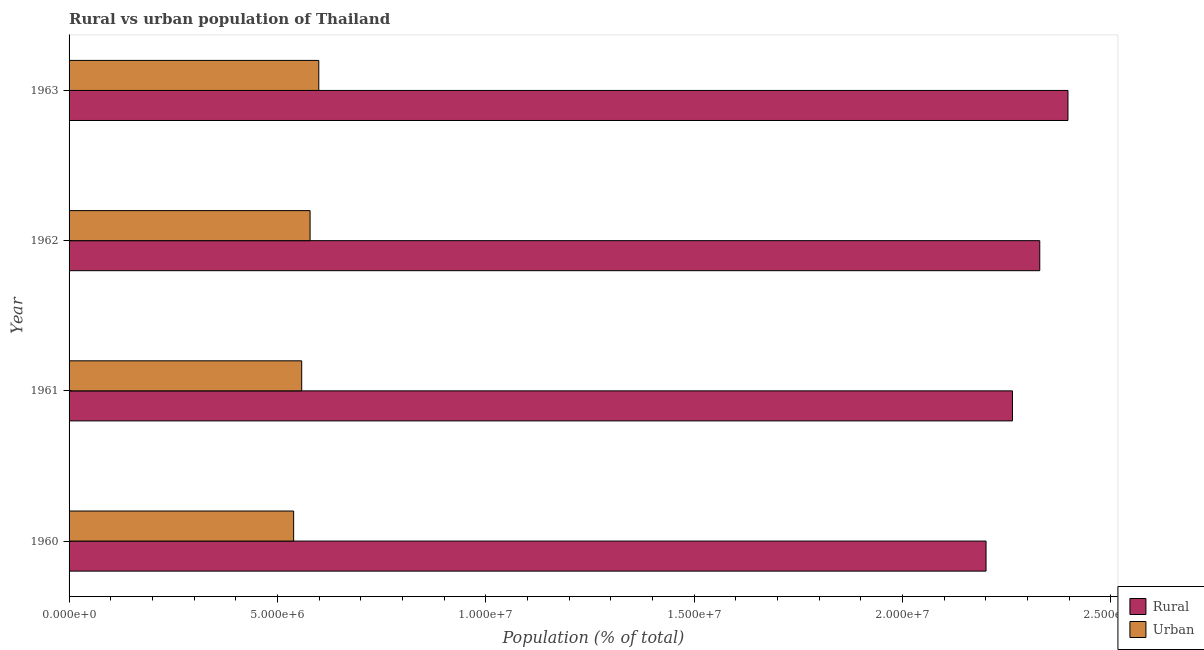How many different coloured bars are there?
Make the answer very short. 2. How many groups of bars are there?
Ensure brevity in your answer.  4. Are the number of bars per tick equal to the number of legend labels?
Keep it short and to the point. Yes. How many bars are there on the 2nd tick from the top?
Your answer should be very brief. 2. How many bars are there on the 3rd tick from the bottom?
Your answer should be compact. 2. What is the label of the 4th group of bars from the top?
Give a very brief answer. 1960. In how many cases, is the number of bars for a given year not equal to the number of legend labels?
Your answer should be compact. 0. What is the urban population density in 1962?
Offer a terse response. 5.78e+06. Across all years, what is the maximum urban population density?
Offer a very short reply. 5.99e+06. Across all years, what is the minimum urban population density?
Keep it short and to the point. 5.39e+06. In which year was the urban population density maximum?
Ensure brevity in your answer.  1963. What is the total urban population density in the graph?
Offer a terse response. 2.28e+07. What is the difference between the rural population density in 1960 and that in 1962?
Keep it short and to the point. -1.29e+06. What is the difference between the urban population density in 1963 and the rural population density in 1961?
Give a very brief answer. -1.66e+07. What is the average urban population density per year?
Your answer should be compact. 5.69e+06. In the year 1963, what is the difference between the rural population density and urban population density?
Your answer should be very brief. 1.80e+07. In how many years, is the rural population density greater than 18000000 %?
Your response must be concise. 4. What is the ratio of the rural population density in 1960 to that in 1963?
Offer a terse response. 0.92. What is the difference between the highest and the second highest rural population density?
Your answer should be very brief. 6.77e+05. What is the difference between the highest and the lowest rural population density?
Provide a succinct answer. 1.97e+06. In how many years, is the rural population density greater than the average rural population density taken over all years?
Your answer should be very brief. 2. What does the 2nd bar from the top in 1961 represents?
Give a very brief answer. Rural. What does the 1st bar from the bottom in 1960 represents?
Make the answer very short. Rural. Are all the bars in the graph horizontal?
Offer a terse response. Yes. What is the difference between two consecutive major ticks on the X-axis?
Give a very brief answer. 5.00e+06. Are the values on the major ticks of X-axis written in scientific E-notation?
Provide a succinct answer. Yes. Where does the legend appear in the graph?
Give a very brief answer. Bottom right. How many legend labels are there?
Offer a very short reply. 2. What is the title of the graph?
Your answer should be very brief. Rural vs urban population of Thailand. Does "US$" appear as one of the legend labels in the graph?
Provide a succinct answer. No. What is the label or title of the X-axis?
Give a very brief answer. Population (% of total). What is the label or title of the Y-axis?
Your answer should be very brief. Year. What is the Population (% of total) of Rural in 1960?
Provide a short and direct response. 2.20e+07. What is the Population (% of total) of Urban in 1960?
Your answer should be compact. 5.39e+06. What is the Population (% of total) of Rural in 1961?
Your answer should be compact. 2.26e+07. What is the Population (% of total) in Urban in 1961?
Offer a terse response. 5.58e+06. What is the Population (% of total) of Rural in 1962?
Offer a terse response. 2.33e+07. What is the Population (% of total) of Urban in 1962?
Your answer should be very brief. 5.78e+06. What is the Population (% of total) in Rural in 1963?
Give a very brief answer. 2.40e+07. What is the Population (% of total) of Urban in 1963?
Provide a short and direct response. 5.99e+06. Across all years, what is the maximum Population (% of total) in Rural?
Make the answer very short. 2.40e+07. Across all years, what is the maximum Population (% of total) of Urban?
Ensure brevity in your answer.  5.99e+06. Across all years, what is the minimum Population (% of total) in Rural?
Offer a very short reply. 2.20e+07. Across all years, what is the minimum Population (% of total) of Urban?
Keep it short and to the point. 5.39e+06. What is the total Population (% of total) in Rural in the graph?
Offer a terse response. 9.19e+07. What is the total Population (% of total) of Urban in the graph?
Keep it short and to the point. 2.28e+07. What is the difference between the Population (% of total) in Rural in 1960 and that in 1961?
Offer a very short reply. -6.34e+05. What is the difference between the Population (% of total) in Urban in 1960 and that in 1961?
Your answer should be compact. -1.93e+05. What is the difference between the Population (% of total) in Rural in 1960 and that in 1962?
Your answer should be very brief. -1.29e+06. What is the difference between the Population (% of total) of Urban in 1960 and that in 1962?
Make the answer very short. -3.95e+05. What is the difference between the Population (% of total) in Rural in 1960 and that in 1963?
Your answer should be very brief. -1.97e+06. What is the difference between the Population (% of total) of Urban in 1960 and that in 1963?
Offer a terse response. -6.04e+05. What is the difference between the Population (% of total) of Rural in 1961 and that in 1962?
Offer a very short reply. -6.56e+05. What is the difference between the Population (% of total) in Urban in 1961 and that in 1962?
Ensure brevity in your answer.  -2.01e+05. What is the difference between the Population (% of total) of Rural in 1961 and that in 1963?
Ensure brevity in your answer.  -1.33e+06. What is the difference between the Population (% of total) of Urban in 1961 and that in 1963?
Offer a very short reply. -4.10e+05. What is the difference between the Population (% of total) in Rural in 1962 and that in 1963?
Your answer should be compact. -6.77e+05. What is the difference between the Population (% of total) in Urban in 1962 and that in 1963?
Offer a very short reply. -2.09e+05. What is the difference between the Population (% of total) in Rural in 1960 and the Population (% of total) in Urban in 1961?
Provide a short and direct response. 1.64e+07. What is the difference between the Population (% of total) in Rural in 1960 and the Population (% of total) in Urban in 1962?
Your response must be concise. 1.62e+07. What is the difference between the Population (% of total) of Rural in 1960 and the Population (% of total) of Urban in 1963?
Offer a terse response. 1.60e+07. What is the difference between the Population (% of total) in Rural in 1961 and the Population (% of total) in Urban in 1962?
Your answer should be very brief. 1.69e+07. What is the difference between the Population (% of total) of Rural in 1961 and the Population (% of total) of Urban in 1963?
Provide a succinct answer. 1.66e+07. What is the difference between the Population (% of total) of Rural in 1962 and the Population (% of total) of Urban in 1963?
Offer a very short reply. 1.73e+07. What is the average Population (% of total) in Rural per year?
Provide a succinct answer. 2.30e+07. What is the average Population (% of total) in Urban per year?
Your answer should be very brief. 5.69e+06. In the year 1960, what is the difference between the Population (% of total) in Rural and Population (% of total) in Urban?
Make the answer very short. 1.66e+07. In the year 1961, what is the difference between the Population (% of total) in Rural and Population (% of total) in Urban?
Offer a very short reply. 1.71e+07. In the year 1962, what is the difference between the Population (% of total) of Rural and Population (% of total) of Urban?
Your answer should be compact. 1.75e+07. In the year 1963, what is the difference between the Population (% of total) in Rural and Population (% of total) in Urban?
Give a very brief answer. 1.80e+07. What is the ratio of the Population (% of total) in Rural in 1960 to that in 1961?
Your answer should be compact. 0.97. What is the ratio of the Population (% of total) in Urban in 1960 to that in 1961?
Your response must be concise. 0.97. What is the ratio of the Population (% of total) of Rural in 1960 to that in 1962?
Ensure brevity in your answer.  0.94. What is the ratio of the Population (% of total) in Urban in 1960 to that in 1962?
Ensure brevity in your answer.  0.93. What is the ratio of the Population (% of total) in Rural in 1960 to that in 1963?
Provide a succinct answer. 0.92. What is the ratio of the Population (% of total) in Urban in 1960 to that in 1963?
Make the answer very short. 0.9. What is the ratio of the Population (% of total) in Rural in 1961 to that in 1962?
Offer a very short reply. 0.97. What is the ratio of the Population (% of total) of Urban in 1961 to that in 1962?
Make the answer very short. 0.97. What is the ratio of the Population (% of total) of Urban in 1961 to that in 1963?
Offer a terse response. 0.93. What is the ratio of the Population (% of total) of Rural in 1962 to that in 1963?
Make the answer very short. 0.97. What is the ratio of the Population (% of total) of Urban in 1962 to that in 1963?
Keep it short and to the point. 0.97. What is the difference between the highest and the second highest Population (% of total) in Rural?
Offer a very short reply. 6.77e+05. What is the difference between the highest and the second highest Population (% of total) of Urban?
Ensure brevity in your answer.  2.09e+05. What is the difference between the highest and the lowest Population (% of total) of Rural?
Give a very brief answer. 1.97e+06. What is the difference between the highest and the lowest Population (% of total) of Urban?
Give a very brief answer. 6.04e+05. 